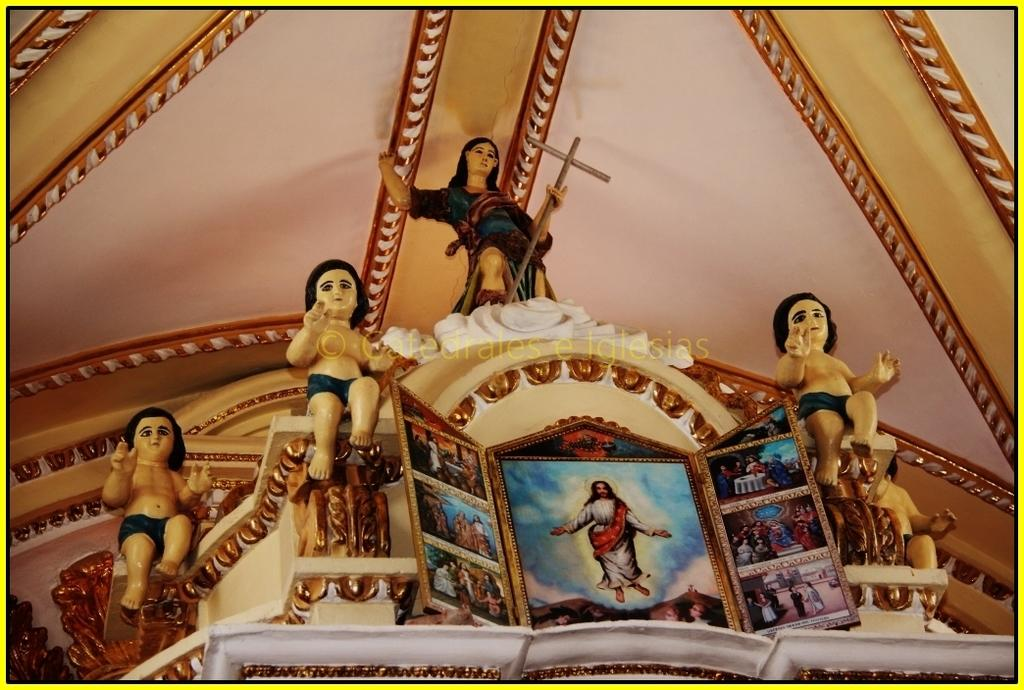What type of objects can be seen in the image? There are mini sculptures and photos in the image. Can you describe the mini sculptures in the image? Unfortunately, the details of the mini sculptures cannot be determined from the provided facts. What can be seen in the photos in the image? The content of the photos cannot be determined from the provided facts. How does the zephyr affect the mini sculptures in the image? There is no mention of a zephyr or any wind in the image, so its effect on the mini sculptures cannot be determined. 